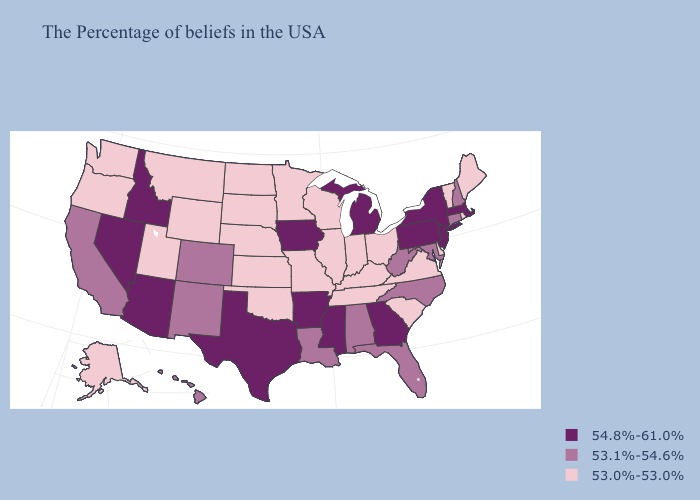Among the states that border Virginia , does Kentucky have the lowest value?
Keep it brief. Yes. What is the lowest value in the Northeast?
Keep it brief. 53.0%-53.0%. What is the lowest value in the South?
Short answer required. 53.0%-53.0%. What is the value of New Jersey?
Give a very brief answer. 54.8%-61.0%. Which states have the lowest value in the MidWest?
Concise answer only. Ohio, Indiana, Wisconsin, Illinois, Missouri, Minnesota, Kansas, Nebraska, South Dakota, North Dakota. Among the states that border Nevada , which have the lowest value?
Be succinct. Utah, Oregon. Name the states that have a value in the range 53.1%-54.6%?
Answer briefly. New Hampshire, Connecticut, Maryland, North Carolina, West Virginia, Florida, Alabama, Louisiana, Colorado, New Mexico, California, Hawaii. What is the value of Hawaii?
Keep it brief. 53.1%-54.6%. Does the first symbol in the legend represent the smallest category?
Answer briefly. No. What is the value of Montana?
Be succinct. 53.0%-53.0%. Name the states that have a value in the range 53.1%-54.6%?
Short answer required. New Hampshire, Connecticut, Maryland, North Carolina, West Virginia, Florida, Alabama, Louisiana, Colorado, New Mexico, California, Hawaii. What is the highest value in the Northeast ?
Give a very brief answer. 54.8%-61.0%. What is the value of Kentucky?
Answer briefly. 53.0%-53.0%. Does Idaho have the highest value in the USA?
Quick response, please. Yes. Which states have the lowest value in the MidWest?
Quick response, please. Ohio, Indiana, Wisconsin, Illinois, Missouri, Minnesota, Kansas, Nebraska, South Dakota, North Dakota. 